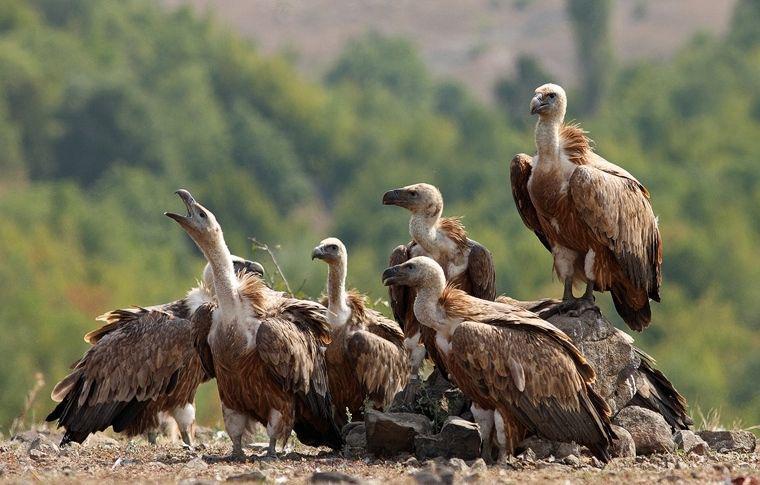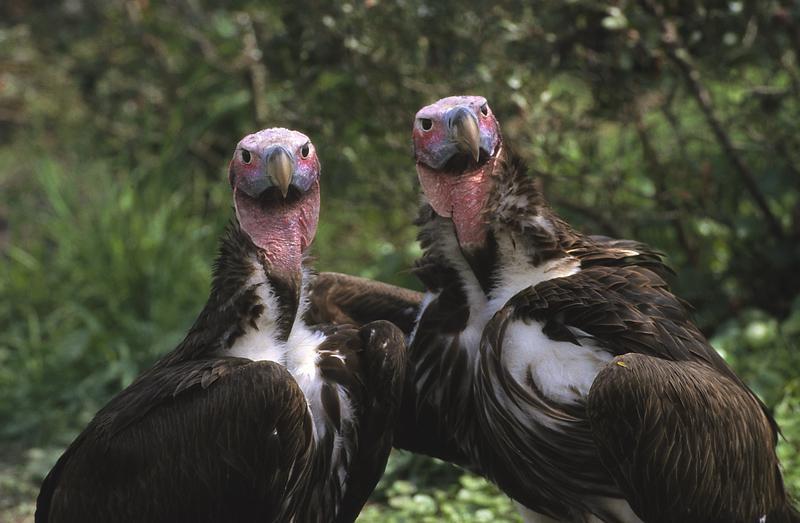The first image is the image on the left, the second image is the image on the right. Analyze the images presented: Is the assertion "An image shows exactly two side-by-side vultures posed with no space between them." valid? Answer yes or no. Yes. The first image is the image on the left, the second image is the image on the right. Examine the images to the left and right. Is the description "There are more than four birds." accurate? Answer yes or no. Yes. 